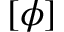Convert formula to latex. <formula><loc_0><loc_0><loc_500><loc_500>[ \phi ]</formula> 